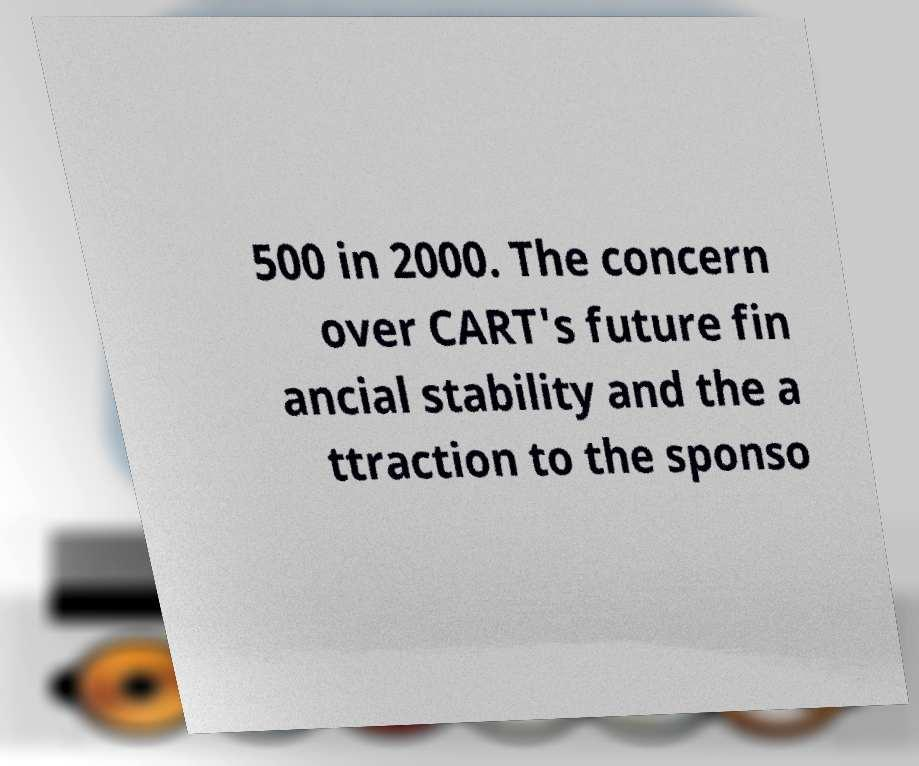What messages or text are displayed in this image? I need them in a readable, typed format. 500 in 2000. The concern over CART's future fin ancial stability and the a ttraction to the sponso 